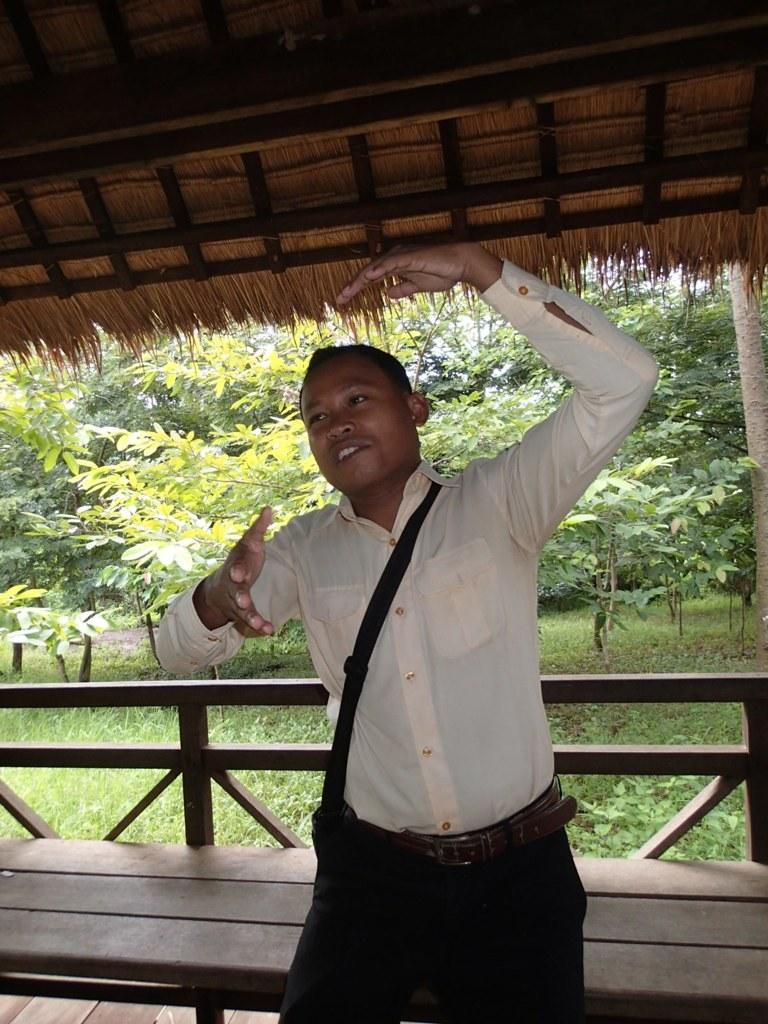Who is present in the image? There is a man in the image. What is the man wearing on his upper body? The man is wearing a shirt. What color are the man's pants? The man is wearing black pants. What type of furniture is in the image? There is a wooden table in the image. What type of natural environment is visible in the image? Trees are visible in the image. What type of advertisement is the man holding in the image? There is no advertisement present in the image; the man is not holding anything. 